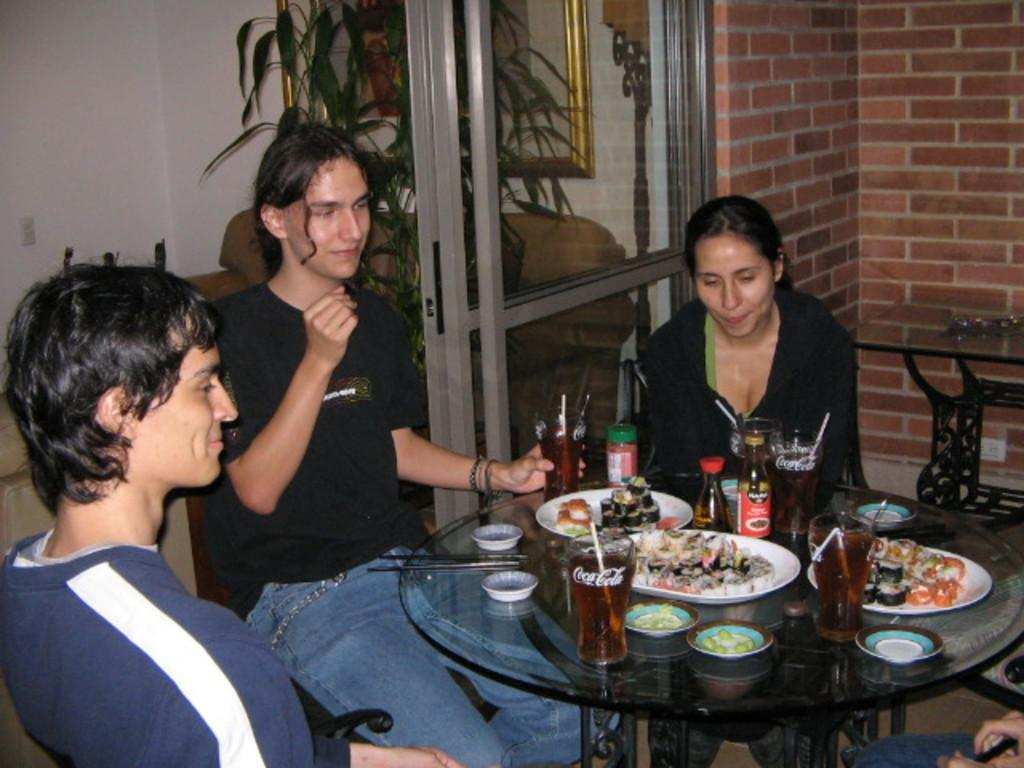How many people are in the image? There are three people in the image. What are the people doing in the image? The people are seated on chairs. What can be seen on the table in the image? There is food and glasses on the table. Who is the uncle sitting on the throne in the image? There is no uncle or throne present in the image. 